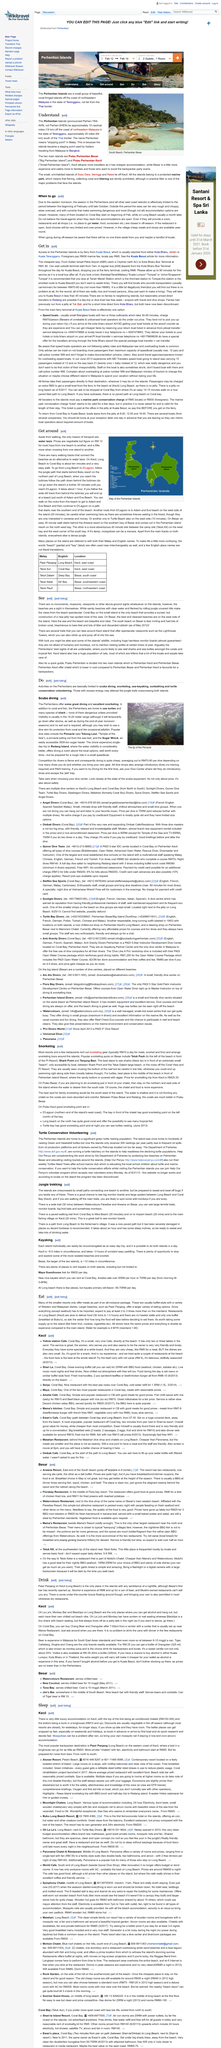Point out several critical features in this image. The Perhentian Islands are located approximately 40 miles (64 kilometers) south of the Thai border. Snorkeling is the activity that is being described. In Coral Bay, it is possible to purchase Chang beer and Orangutan from a vendor. Pasir Panjang is the most popular backpacker destination in Kecil. The location of Yellow Station Cafe is stated as Coral Bay, Kecil. 